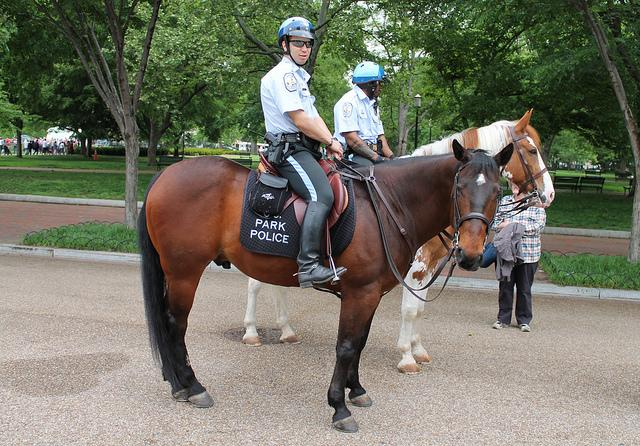Where are these policemen patrolling? park 